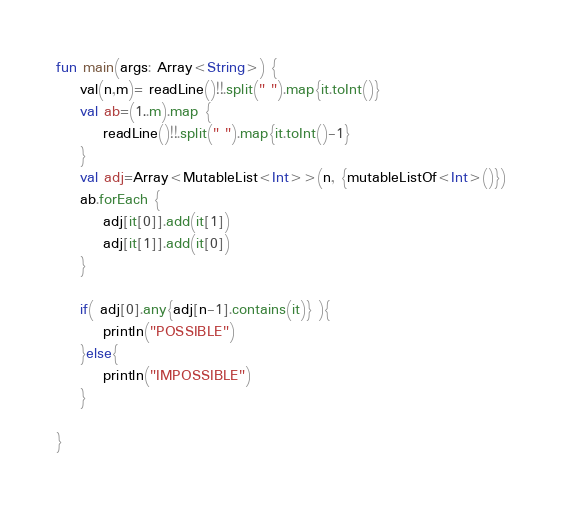<code> <loc_0><loc_0><loc_500><loc_500><_Kotlin_>fun main(args: Array<String>) {
    val(n,m)= readLine()!!.split(" ").map{it.toInt()}
    val ab=(1..m).map {
        readLine()!!.split(" ").map{it.toInt()-1}
    }
    val adj=Array<MutableList<Int>>(n, {mutableListOf<Int>()})
    ab.forEach {
        adj[it[0]].add(it[1])
        adj[it[1]].add(it[0])
    }

    if( adj[0].any{adj[n-1].contains(it)} ){
        println("POSSIBLE")
    }else{
        println("IMPOSSIBLE")
    }

}</code> 